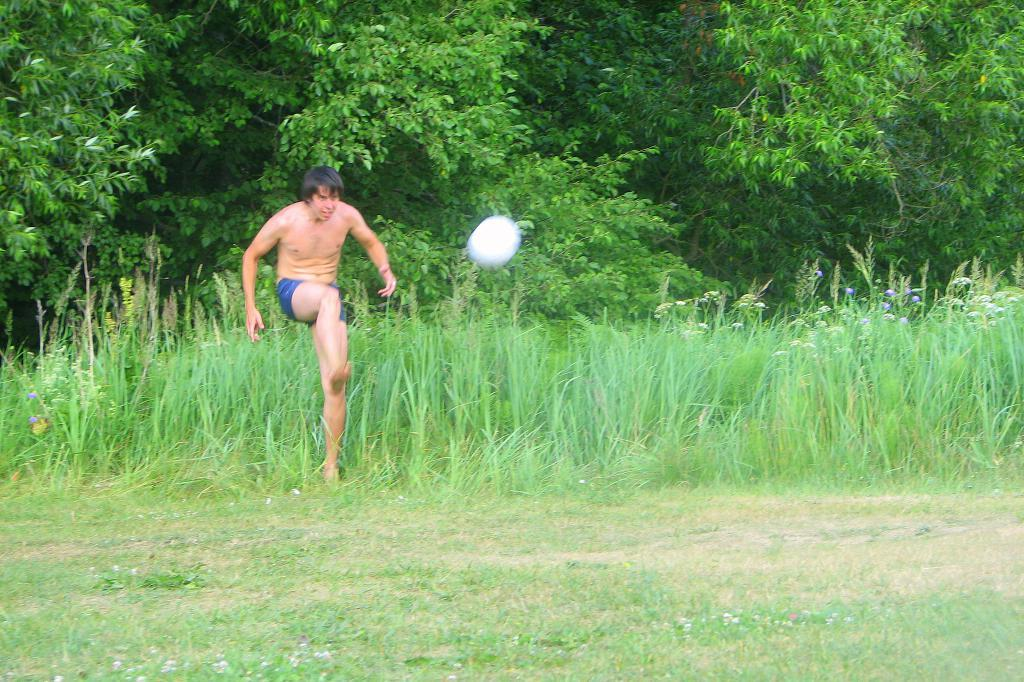Who is present in the image? There is a man in the image. What object is located in the center of the image? There is a ball in the center of the image. What type of surface is at the bottom of the image? There is grass at the bottom of the image. What can be seen in the distance in the image? There are trees in the background of the image. Where is the rabbit sitting in the image? There is no rabbit present in the image. What message of peace is conveyed by the image? The image does not convey any specific message of peace; it simply shows a man, a ball, grass, and trees. 